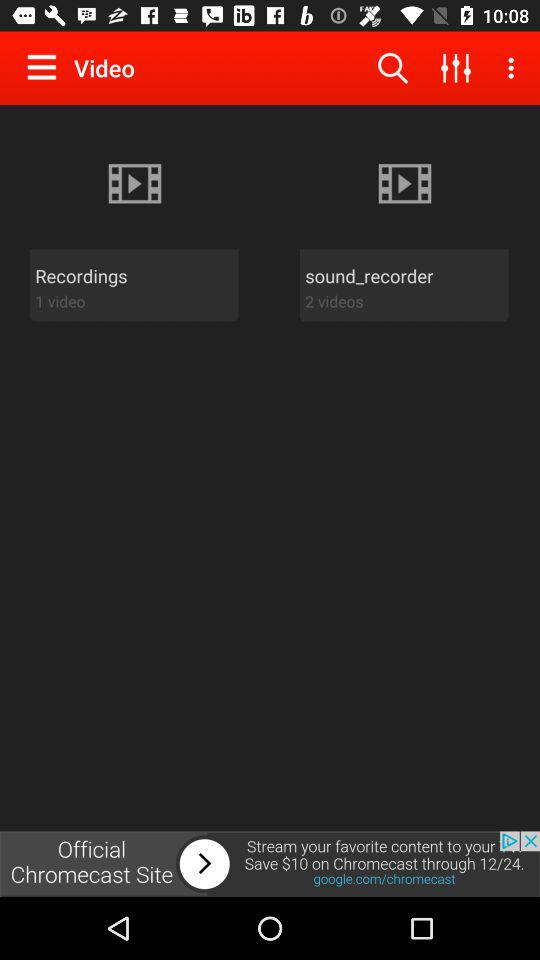How many videos are in the "Recordings"? In the "Recordings", there is 1 video. 